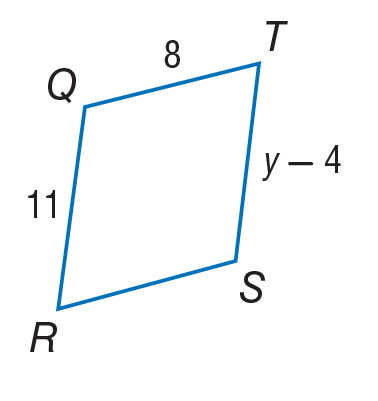Question: Find y in the given parallelogram.
Choices:
A. 8
B. 11
C. 15
D. 19
Answer with the letter. Answer: C 